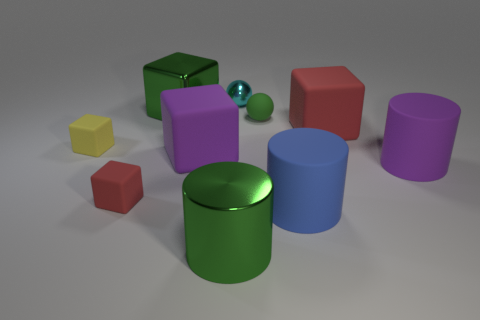Subtract all large purple matte blocks. How many blocks are left? 4 Subtract all green blocks. How many blocks are left? 4 Subtract 2 blocks. How many blocks are left? 3 Subtract all gray cubes. Subtract all red cylinders. How many cubes are left? 5 Subtract all cylinders. How many objects are left? 7 Subtract all red metallic blocks. Subtract all shiny blocks. How many objects are left? 9 Add 6 large green cylinders. How many large green cylinders are left? 7 Add 7 tiny cyan rubber blocks. How many tiny cyan rubber blocks exist? 7 Subtract 0 red balls. How many objects are left? 10 